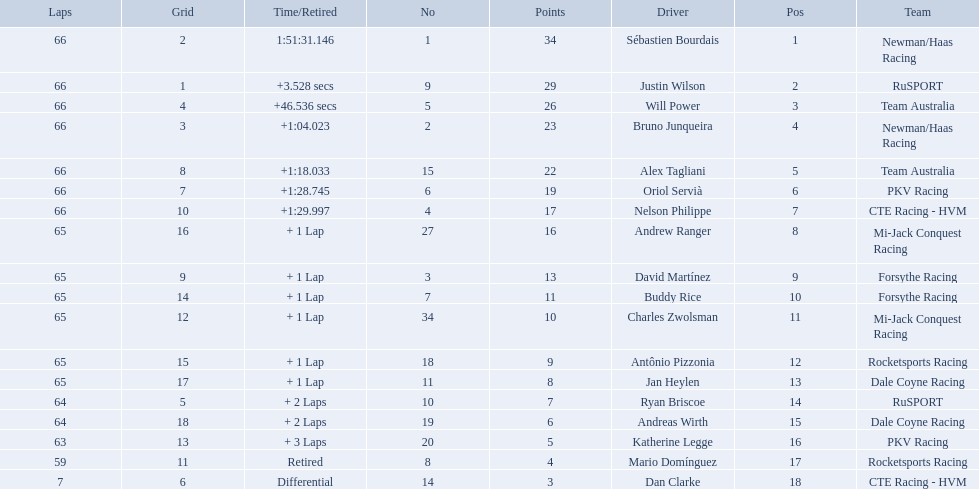What drivers started in the top 10? Sébastien Bourdais, Justin Wilson, Will Power, Bruno Junqueira, Alex Tagliani, Oriol Servià, Nelson Philippe, Ryan Briscoe, Dan Clarke. Which of those drivers completed all 66 laps? Sébastien Bourdais, Justin Wilson, Will Power, Bruno Junqueira, Alex Tagliani, Oriol Servià, Nelson Philippe. Whom of these did not drive for team australia? Sébastien Bourdais, Justin Wilson, Bruno Junqueira, Oriol Servià, Nelson Philippe. Which of these drivers finished more then a minuet after the winner? Bruno Junqueira, Oriol Servià, Nelson Philippe. Which of these drivers had the highest car number? Oriol Servià. How many laps did oriol servia complete at the 2006 gran premio? 66. How many laps did katherine legge complete at the 2006 gran premio? 63. Between servia and legge, who completed more laps? Oriol Servià. What was the highest amount of points scored in the 2006 gran premio? 34. Who scored 34 points? Sébastien Bourdais. 